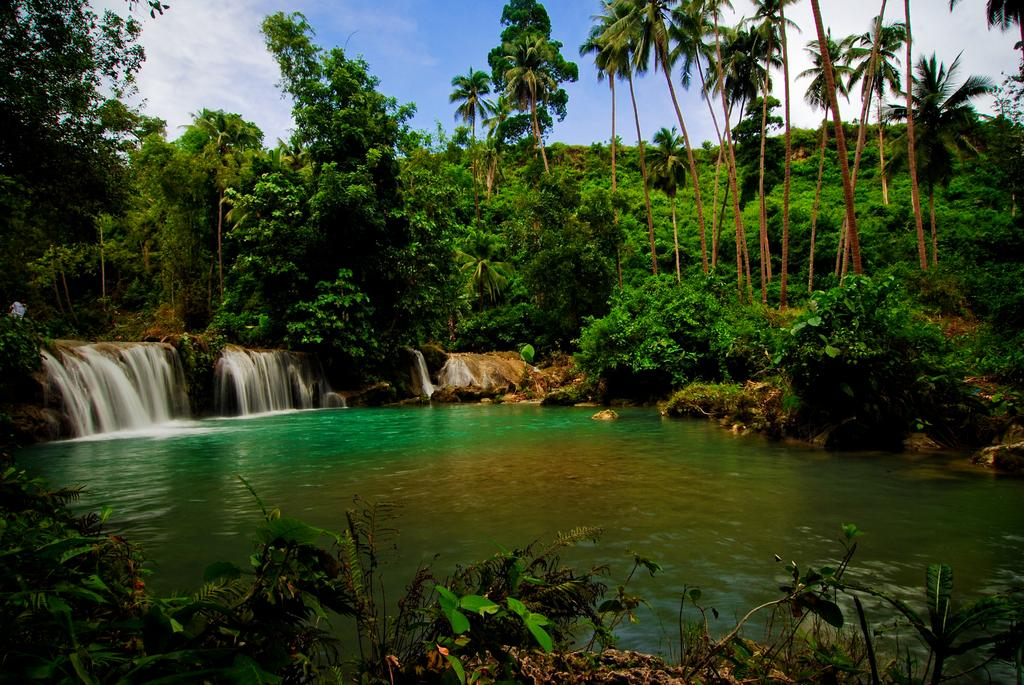What type of living organisms can be seen in the image? Plants are visible in the image. What is the primary element in the image? Water is visible in the image. What geological features are present in the image? Huge rocks are present in the image. What is happening with the water and rocks in the image? Water is falling from the rocks in the image. What can be seen in the background of the image? Trees and the sky are visible in the background of the image. What brand of toothpaste is being advertised in the image? There is no toothpaste or advertisement present in the image. What direction are the plants facing in the image? The direction the plants are facing cannot be determined from the image. 